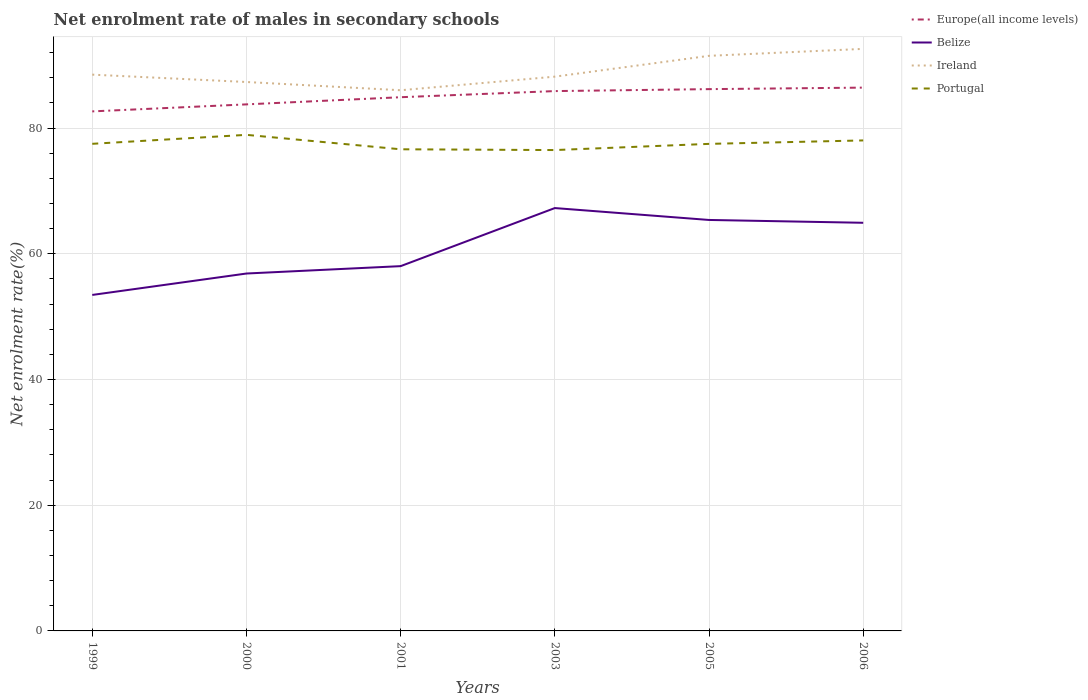How many different coloured lines are there?
Offer a very short reply. 4. Does the line corresponding to Ireland intersect with the line corresponding to Portugal?
Your answer should be very brief. No. Is the number of lines equal to the number of legend labels?
Offer a very short reply. Yes. Across all years, what is the maximum net enrolment rate of males in secondary schools in Belize?
Your answer should be compact. 53.45. In which year was the net enrolment rate of males in secondary schools in Belize maximum?
Provide a short and direct response. 1999. What is the total net enrolment rate of males in secondary schools in Europe(all income levels) in the graph?
Your response must be concise. -2.26. What is the difference between the highest and the second highest net enrolment rate of males in secondary schools in Europe(all income levels)?
Ensure brevity in your answer.  3.78. Is the net enrolment rate of males in secondary schools in Ireland strictly greater than the net enrolment rate of males in secondary schools in Europe(all income levels) over the years?
Make the answer very short. No. How many lines are there?
Ensure brevity in your answer.  4. Where does the legend appear in the graph?
Your response must be concise. Top right. What is the title of the graph?
Give a very brief answer. Net enrolment rate of males in secondary schools. Does "Lower middle income" appear as one of the legend labels in the graph?
Your answer should be very brief. No. What is the label or title of the X-axis?
Offer a terse response. Years. What is the label or title of the Y-axis?
Keep it short and to the point. Net enrolment rate(%). What is the Net enrolment rate(%) of Europe(all income levels) in 1999?
Provide a succinct answer. 82.65. What is the Net enrolment rate(%) in Belize in 1999?
Provide a succinct answer. 53.45. What is the Net enrolment rate(%) in Ireland in 1999?
Make the answer very short. 88.5. What is the Net enrolment rate(%) in Portugal in 1999?
Provide a succinct answer. 77.49. What is the Net enrolment rate(%) of Europe(all income levels) in 2000?
Give a very brief answer. 83.77. What is the Net enrolment rate(%) in Belize in 2000?
Give a very brief answer. 56.86. What is the Net enrolment rate(%) of Ireland in 2000?
Make the answer very short. 87.33. What is the Net enrolment rate(%) in Portugal in 2000?
Provide a succinct answer. 78.92. What is the Net enrolment rate(%) in Europe(all income levels) in 2001?
Your response must be concise. 84.9. What is the Net enrolment rate(%) in Belize in 2001?
Offer a terse response. 58.03. What is the Net enrolment rate(%) in Ireland in 2001?
Your response must be concise. 86.01. What is the Net enrolment rate(%) in Portugal in 2001?
Ensure brevity in your answer.  76.62. What is the Net enrolment rate(%) of Europe(all income levels) in 2003?
Provide a short and direct response. 85.88. What is the Net enrolment rate(%) of Belize in 2003?
Your response must be concise. 67.27. What is the Net enrolment rate(%) of Ireland in 2003?
Offer a terse response. 88.18. What is the Net enrolment rate(%) in Portugal in 2003?
Give a very brief answer. 76.5. What is the Net enrolment rate(%) in Europe(all income levels) in 2005?
Give a very brief answer. 86.19. What is the Net enrolment rate(%) in Belize in 2005?
Ensure brevity in your answer.  65.38. What is the Net enrolment rate(%) in Ireland in 2005?
Ensure brevity in your answer.  91.49. What is the Net enrolment rate(%) in Portugal in 2005?
Your answer should be compact. 77.48. What is the Net enrolment rate(%) in Europe(all income levels) in 2006?
Your answer should be very brief. 86.43. What is the Net enrolment rate(%) of Belize in 2006?
Make the answer very short. 64.93. What is the Net enrolment rate(%) in Ireland in 2006?
Make the answer very short. 92.59. What is the Net enrolment rate(%) in Portugal in 2006?
Your answer should be very brief. 78.03. Across all years, what is the maximum Net enrolment rate(%) in Europe(all income levels)?
Offer a terse response. 86.43. Across all years, what is the maximum Net enrolment rate(%) in Belize?
Offer a very short reply. 67.27. Across all years, what is the maximum Net enrolment rate(%) of Ireland?
Make the answer very short. 92.59. Across all years, what is the maximum Net enrolment rate(%) of Portugal?
Your answer should be compact. 78.92. Across all years, what is the minimum Net enrolment rate(%) of Europe(all income levels)?
Provide a succinct answer. 82.65. Across all years, what is the minimum Net enrolment rate(%) of Belize?
Your answer should be compact. 53.45. Across all years, what is the minimum Net enrolment rate(%) of Ireland?
Offer a very short reply. 86.01. Across all years, what is the minimum Net enrolment rate(%) in Portugal?
Offer a terse response. 76.5. What is the total Net enrolment rate(%) in Europe(all income levels) in the graph?
Your answer should be very brief. 509.82. What is the total Net enrolment rate(%) of Belize in the graph?
Your answer should be very brief. 365.92. What is the total Net enrolment rate(%) in Ireland in the graph?
Make the answer very short. 534.1. What is the total Net enrolment rate(%) of Portugal in the graph?
Your answer should be very brief. 465.05. What is the difference between the Net enrolment rate(%) of Europe(all income levels) in 1999 and that in 2000?
Make the answer very short. -1.12. What is the difference between the Net enrolment rate(%) of Belize in 1999 and that in 2000?
Your answer should be compact. -3.41. What is the difference between the Net enrolment rate(%) of Ireland in 1999 and that in 2000?
Ensure brevity in your answer.  1.17. What is the difference between the Net enrolment rate(%) in Portugal in 1999 and that in 2000?
Offer a very short reply. -1.43. What is the difference between the Net enrolment rate(%) in Europe(all income levels) in 1999 and that in 2001?
Your answer should be compact. -2.26. What is the difference between the Net enrolment rate(%) of Belize in 1999 and that in 2001?
Make the answer very short. -4.58. What is the difference between the Net enrolment rate(%) in Ireland in 1999 and that in 2001?
Provide a succinct answer. 2.48. What is the difference between the Net enrolment rate(%) in Portugal in 1999 and that in 2001?
Your answer should be very brief. 0.87. What is the difference between the Net enrolment rate(%) in Europe(all income levels) in 1999 and that in 2003?
Make the answer very short. -3.23. What is the difference between the Net enrolment rate(%) of Belize in 1999 and that in 2003?
Provide a succinct answer. -13.82. What is the difference between the Net enrolment rate(%) in Ireland in 1999 and that in 2003?
Give a very brief answer. 0.32. What is the difference between the Net enrolment rate(%) in Portugal in 1999 and that in 2003?
Your response must be concise. 0.99. What is the difference between the Net enrolment rate(%) of Europe(all income levels) in 1999 and that in 2005?
Make the answer very short. -3.54. What is the difference between the Net enrolment rate(%) of Belize in 1999 and that in 2005?
Provide a short and direct response. -11.93. What is the difference between the Net enrolment rate(%) in Ireland in 1999 and that in 2005?
Give a very brief answer. -2.99. What is the difference between the Net enrolment rate(%) in Portugal in 1999 and that in 2005?
Provide a short and direct response. 0.01. What is the difference between the Net enrolment rate(%) of Europe(all income levels) in 1999 and that in 2006?
Keep it short and to the point. -3.78. What is the difference between the Net enrolment rate(%) of Belize in 1999 and that in 2006?
Ensure brevity in your answer.  -11.48. What is the difference between the Net enrolment rate(%) of Ireland in 1999 and that in 2006?
Give a very brief answer. -4.1. What is the difference between the Net enrolment rate(%) in Portugal in 1999 and that in 2006?
Keep it short and to the point. -0.54. What is the difference between the Net enrolment rate(%) in Europe(all income levels) in 2000 and that in 2001?
Offer a very short reply. -1.14. What is the difference between the Net enrolment rate(%) of Belize in 2000 and that in 2001?
Provide a short and direct response. -1.17. What is the difference between the Net enrolment rate(%) of Ireland in 2000 and that in 2001?
Make the answer very short. 1.31. What is the difference between the Net enrolment rate(%) in Portugal in 2000 and that in 2001?
Make the answer very short. 2.3. What is the difference between the Net enrolment rate(%) in Europe(all income levels) in 2000 and that in 2003?
Your answer should be compact. -2.11. What is the difference between the Net enrolment rate(%) of Belize in 2000 and that in 2003?
Give a very brief answer. -10.41. What is the difference between the Net enrolment rate(%) of Ireland in 2000 and that in 2003?
Provide a succinct answer. -0.85. What is the difference between the Net enrolment rate(%) of Portugal in 2000 and that in 2003?
Your answer should be very brief. 2.42. What is the difference between the Net enrolment rate(%) in Europe(all income levels) in 2000 and that in 2005?
Keep it short and to the point. -2.42. What is the difference between the Net enrolment rate(%) in Belize in 2000 and that in 2005?
Provide a succinct answer. -8.52. What is the difference between the Net enrolment rate(%) in Ireland in 2000 and that in 2005?
Give a very brief answer. -4.16. What is the difference between the Net enrolment rate(%) in Portugal in 2000 and that in 2005?
Give a very brief answer. 1.44. What is the difference between the Net enrolment rate(%) of Europe(all income levels) in 2000 and that in 2006?
Provide a succinct answer. -2.67. What is the difference between the Net enrolment rate(%) of Belize in 2000 and that in 2006?
Provide a succinct answer. -8.07. What is the difference between the Net enrolment rate(%) of Ireland in 2000 and that in 2006?
Your response must be concise. -5.27. What is the difference between the Net enrolment rate(%) of Portugal in 2000 and that in 2006?
Your answer should be compact. 0.89. What is the difference between the Net enrolment rate(%) of Europe(all income levels) in 2001 and that in 2003?
Ensure brevity in your answer.  -0.97. What is the difference between the Net enrolment rate(%) of Belize in 2001 and that in 2003?
Provide a short and direct response. -9.24. What is the difference between the Net enrolment rate(%) in Ireland in 2001 and that in 2003?
Your answer should be very brief. -2.16. What is the difference between the Net enrolment rate(%) in Portugal in 2001 and that in 2003?
Your answer should be compact. 0.12. What is the difference between the Net enrolment rate(%) of Europe(all income levels) in 2001 and that in 2005?
Offer a terse response. -1.29. What is the difference between the Net enrolment rate(%) in Belize in 2001 and that in 2005?
Provide a short and direct response. -7.35. What is the difference between the Net enrolment rate(%) in Ireland in 2001 and that in 2005?
Your answer should be compact. -5.47. What is the difference between the Net enrolment rate(%) of Portugal in 2001 and that in 2005?
Provide a short and direct response. -0.86. What is the difference between the Net enrolment rate(%) in Europe(all income levels) in 2001 and that in 2006?
Provide a short and direct response. -1.53. What is the difference between the Net enrolment rate(%) of Belize in 2001 and that in 2006?
Keep it short and to the point. -6.9. What is the difference between the Net enrolment rate(%) of Ireland in 2001 and that in 2006?
Offer a terse response. -6.58. What is the difference between the Net enrolment rate(%) of Portugal in 2001 and that in 2006?
Keep it short and to the point. -1.41. What is the difference between the Net enrolment rate(%) of Europe(all income levels) in 2003 and that in 2005?
Your answer should be compact. -0.31. What is the difference between the Net enrolment rate(%) in Belize in 2003 and that in 2005?
Ensure brevity in your answer.  1.89. What is the difference between the Net enrolment rate(%) in Ireland in 2003 and that in 2005?
Provide a short and direct response. -3.31. What is the difference between the Net enrolment rate(%) of Portugal in 2003 and that in 2005?
Give a very brief answer. -0.98. What is the difference between the Net enrolment rate(%) of Europe(all income levels) in 2003 and that in 2006?
Offer a very short reply. -0.55. What is the difference between the Net enrolment rate(%) of Belize in 2003 and that in 2006?
Offer a very short reply. 2.34. What is the difference between the Net enrolment rate(%) in Ireland in 2003 and that in 2006?
Your answer should be compact. -4.42. What is the difference between the Net enrolment rate(%) of Portugal in 2003 and that in 2006?
Keep it short and to the point. -1.53. What is the difference between the Net enrolment rate(%) of Europe(all income levels) in 2005 and that in 2006?
Provide a short and direct response. -0.24. What is the difference between the Net enrolment rate(%) of Belize in 2005 and that in 2006?
Keep it short and to the point. 0.45. What is the difference between the Net enrolment rate(%) of Ireland in 2005 and that in 2006?
Provide a short and direct response. -1.11. What is the difference between the Net enrolment rate(%) in Portugal in 2005 and that in 2006?
Ensure brevity in your answer.  -0.55. What is the difference between the Net enrolment rate(%) of Europe(all income levels) in 1999 and the Net enrolment rate(%) of Belize in 2000?
Your answer should be very brief. 25.79. What is the difference between the Net enrolment rate(%) of Europe(all income levels) in 1999 and the Net enrolment rate(%) of Ireland in 2000?
Ensure brevity in your answer.  -4.68. What is the difference between the Net enrolment rate(%) in Europe(all income levels) in 1999 and the Net enrolment rate(%) in Portugal in 2000?
Keep it short and to the point. 3.73. What is the difference between the Net enrolment rate(%) of Belize in 1999 and the Net enrolment rate(%) of Ireland in 2000?
Ensure brevity in your answer.  -33.88. What is the difference between the Net enrolment rate(%) in Belize in 1999 and the Net enrolment rate(%) in Portugal in 2000?
Your response must be concise. -25.47. What is the difference between the Net enrolment rate(%) of Ireland in 1999 and the Net enrolment rate(%) of Portugal in 2000?
Offer a terse response. 9.58. What is the difference between the Net enrolment rate(%) of Europe(all income levels) in 1999 and the Net enrolment rate(%) of Belize in 2001?
Offer a very short reply. 24.62. What is the difference between the Net enrolment rate(%) in Europe(all income levels) in 1999 and the Net enrolment rate(%) in Ireland in 2001?
Provide a short and direct response. -3.36. What is the difference between the Net enrolment rate(%) of Europe(all income levels) in 1999 and the Net enrolment rate(%) of Portugal in 2001?
Your response must be concise. 6.03. What is the difference between the Net enrolment rate(%) of Belize in 1999 and the Net enrolment rate(%) of Ireland in 2001?
Give a very brief answer. -32.56. What is the difference between the Net enrolment rate(%) of Belize in 1999 and the Net enrolment rate(%) of Portugal in 2001?
Ensure brevity in your answer.  -23.17. What is the difference between the Net enrolment rate(%) in Ireland in 1999 and the Net enrolment rate(%) in Portugal in 2001?
Make the answer very short. 11.87. What is the difference between the Net enrolment rate(%) of Europe(all income levels) in 1999 and the Net enrolment rate(%) of Belize in 2003?
Make the answer very short. 15.38. What is the difference between the Net enrolment rate(%) of Europe(all income levels) in 1999 and the Net enrolment rate(%) of Ireland in 2003?
Offer a terse response. -5.53. What is the difference between the Net enrolment rate(%) of Europe(all income levels) in 1999 and the Net enrolment rate(%) of Portugal in 2003?
Your answer should be compact. 6.15. What is the difference between the Net enrolment rate(%) of Belize in 1999 and the Net enrolment rate(%) of Ireland in 2003?
Your answer should be compact. -34.73. What is the difference between the Net enrolment rate(%) in Belize in 1999 and the Net enrolment rate(%) in Portugal in 2003?
Your answer should be very brief. -23.05. What is the difference between the Net enrolment rate(%) in Ireland in 1999 and the Net enrolment rate(%) in Portugal in 2003?
Your answer should be compact. 12. What is the difference between the Net enrolment rate(%) of Europe(all income levels) in 1999 and the Net enrolment rate(%) of Belize in 2005?
Your response must be concise. 17.27. What is the difference between the Net enrolment rate(%) in Europe(all income levels) in 1999 and the Net enrolment rate(%) in Ireland in 2005?
Your answer should be very brief. -8.84. What is the difference between the Net enrolment rate(%) in Europe(all income levels) in 1999 and the Net enrolment rate(%) in Portugal in 2005?
Make the answer very short. 5.17. What is the difference between the Net enrolment rate(%) in Belize in 1999 and the Net enrolment rate(%) in Ireland in 2005?
Give a very brief answer. -38.04. What is the difference between the Net enrolment rate(%) in Belize in 1999 and the Net enrolment rate(%) in Portugal in 2005?
Offer a very short reply. -24.03. What is the difference between the Net enrolment rate(%) in Ireland in 1999 and the Net enrolment rate(%) in Portugal in 2005?
Ensure brevity in your answer.  11.01. What is the difference between the Net enrolment rate(%) of Europe(all income levels) in 1999 and the Net enrolment rate(%) of Belize in 2006?
Offer a terse response. 17.72. What is the difference between the Net enrolment rate(%) in Europe(all income levels) in 1999 and the Net enrolment rate(%) in Ireland in 2006?
Ensure brevity in your answer.  -9.95. What is the difference between the Net enrolment rate(%) in Europe(all income levels) in 1999 and the Net enrolment rate(%) in Portugal in 2006?
Provide a short and direct response. 4.62. What is the difference between the Net enrolment rate(%) in Belize in 1999 and the Net enrolment rate(%) in Ireland in 2006?
Your answer should be very brief. -39.14. What is the difference between the Net enrolment rate(%) in Belize in 1999 and the Net enrolment rate(%) in Portugal in 2006?
Offer a terse response. -24.58. What is the difference between the Net enrolment rate(%) in Ireland in 1999 and the Net enrolment rate(%) in Portugal in 2006?
Offer a terse response. 10.46. What is the difference between the Net enrolment rate(%) in Europe(all income levels) in 2000 and the Net enrolment rate(%) in Belize in 2001?
Make the answer very short. 25.73. What is the difference between the Net enrolment rate(%) of Europe(all income levels) in 2000 and the Net enrolment rate(%) of Ireland in 2001?
Provide a succinct answer. -2.25. What is the difference between the Net enrolment rate(%) of Europe(all income levels) in 2000 and the Net enrolment rate(%) of Portugal in 2001?
Make the answer very short. 7.14. What is the difference between the Net enrolment rate(%) in Belize in 2000 and the Net enrolment rate(%) in Ireland in 2001?
Ensure brevity in your answer.  -29.16. What is the difference between the Net enrolment rate(%) in Belize in 2000 and the Net enrolment rate(%) in Portugal in 2001?
Ensure brevity in your answer.  -19.77. What is the difference between the Net enrolment rate(%) of Ireland in 2000 and the Net enrolment rate(%) of Portugal in 2001?
Give a very brief answer. 10.7. What is the difference between the Net enrolment rate(%) in Europe(all income levels) in 2000 and the Net enrolment rate(%) in Belize in 2003?
Ensure brevity in your answer.  16.5. What is the difference between the Net enrolment rate(%) in Europe(all income levels) in 2000 and the Net enrolment rate(%) in Ireland in 2003?
Your answer should be very brief. -4.41. What is the difference between the Net enrolment rate(%) in Europe(all income levels) in 2000 and the Net enrolment rate(%) in Portugal in 2003?
Offer a terse response. 7.27. What is the difference between the Net enrolment rate(%) of Belize in 2000 and the Net enrolment rate(%) of Ireland in 2003?
Ensure brevity in your answer.  -31.32. What is the difference between the Net enrolment rate(%) in Belize in 2000 and the Net enrolment rate(%) in Portugal in 2003?
Ensure brevity in your answer.  -19.64. What is the difference between the Net enrolment rate(%) of Ireland in 2000 and the Net enrolment rate(%) of Portugal in 2003?
Your response must be concise. 10.83. What is the difference between the Net enrolment rate(%) of Europe(all income levels) in 2000 and the Net enrolment rate(%) of Belize in 2005?
Provide a succinct answer. 18.39. What is the difference between the Net enrolment rate(%) in Europe(all income levels) in 2000 and the Net enrolment rate(%) in Ireland in 2005?
Your answer should be compact. -7.72. What is the difference between the Net enrolment rate(%) of Europe(all income levels) in 2000 and the Net enrolment rate(%) of Portugal in 2005?
Offer a terse response. 6.28. What is the difference between the Net enrolment rate(%) in Belize in 2000 and the Net enrolment rate(%) in Ireland in 2005?
Keep it short and to the point. -34.63. What is the difference between the Net enrolment rate(%) of Belize in 2000 and the Net enrolment rate(%) of Portugal in 2005?
Your answer should be compact. -20.63. What is the difference between the Net enrolment rate(%) in Ireland in 2000 and the Net enrolment rate(%) in Portugal in 2005?
Your answer should be very brief. 9.84. What is the difference between the Net enrolment rate(%) in Europe(all income levels) in 2000 and the Net enrolment rate(%) in Belize in 2006?
Your answer should be compact. 18.84. What is the difference between the Net enrolment rate(%) of Europe(all income levels) in 2000 and the Net enrolment rate(%) of Ireland in 2006?
Your response must be concise. -8.83. What is the difference between the Net enrolment rate(%) of Europe(all income levels) in 2000 and the Net enrolment rate(%) of Portugal in 2006?
Your response must be concise. 5.73. What is the difference between the Net enrolment rate(%) of Belize in 2000 and the Net enrolment rate(%) of Ireland in 2006?
Your response must be concise. -35.74. What is the difference between the Net enrolment rate(%) in Belize in 2000 and the Net enrolment rate(%) in Portugal in 2006?
Your response must be concise. -21.17. What is the difference between the Net enrolment rate(%) in Ireland in 2000 and the Net enrolment rate(%) in Portugal in 2006?
Ensure brevity in your answer.  9.29. What is the difference between the Net enrolment rate(%) of Europe(all income levels) in 2001 and the Net enrolment rate(%) of Belize in 2003?
Give a very brief answer. 17.63. What is the difference between the Net enrolment rate(%) in Europe(all income levels) in 2001 and the Net enrolment rate(%) in Ireland in 2003?
Make the answer very short. -3.27. What is the difference between the Net enrolment rate(%) in Europe(all income levels) in 2001 and the Net enrolment rate(%) in Portugal in 2003?
Offer a terse response. 8.41. What is the difference between the Net enrolment rate(%) of Belize in 2001 and the Net enrolment rate(%) of Ireland in 2003?
Your answer should be compact. -30.15. What is the difference between the Net enrolment rate(%) of Belize in 2001 and the Net enrolment rate(%) of Portugal in 2003?
Provide a succinct answer. -18.47. What is the difference between the Net enrolment rate(%) of Ireland in 2001 and the Net enrolment rate(%) of Portugal in 2003?
Your response must be concise. 9.52. What is the difference between the Net enrolment rate(%) in Europe(all income levels) in 2001 and the Net enrolment rate(%) in Belize in 2005?
Provide a short and direct response. 19.53. What is the difference between the Net enrolment rate(%) in Europe(all income levels) in 2001 and the Net enrolment rate(%) in Ireland in 2005?
Offer a terse response. -6.58. What is the difference between the Net enrolment rate(%) in Europe(all income levels) in 2001 and the Net enrolment rate(%) in Portugal in 2005?
Ensure brevity in your answer.  7.42. What is the difference between the Net enrolment rate(%) in Belize in 2001 and the Net enrolment rate(%) in Ireland in 2005?
Your answer should be compact. -33.46. What is the difference between the Net enrolment rate(%) of Belize in 2001 and the Net enrolment rate(%) of Portugal in 2005?
Keep it short and to the point. -19.45. What is the difference between the Net enrolment rate(%) of Ireland in 2001 and the Net enrolment rate(%) of Portugal in 2005?
Your answer should be very brief. 8.53. What is the difference between the Net enrolment rate(%) of Europe(all income levels) in 2001 and the Net enrolment rate(%) of Belize in 2006?
Make the answer very short. 19.98. What is the difference between the Net enrolment rate(%) of Europe(all income levels) in 2001 and the Net enrolment rate(%) of Ireland in 2006?
Keep it short and to the point. -7.69. What is the difference between the Net enrolment rate(%) of Europe(all income levels) in 2001 and the Net enrolment rate(%) of Portugal in 2006?
Offer a terse response. 6.87. What is the difference between the Net enrolment rate(%) of Belize in 2001 and the Net enrolment rate(%) of Ireland in 2006?
Make the answer very short. -34.56. What is the difference between the Net enrolment rate(%) of Belize in 2001 and the Net enrolment rate(%) of Portugal in 2006?
Offer a very short reply. -20. What is the difference between the Net enrolment rate(%) of Ireland in 2001 and the Net enrolment rate(%) of Portugal in 2006?
Your answer should be compact. 7.98. What is the difference between the Net enrolment rate(%) in Europe(all income levels) in 2003 and the Net enrolment rate(%) in Belize in 2005?
Your answer should be compact. 20.5. What is the difference between the Net enrolment rate(%) in Europe(all income levels) in 2003 and the Net enrolment rate(%) in Ireland in 2005?
Provide a succinct answer. -5.61. What is the difference between the Net enrolment rate(%) in Europe(all income levels) in 2003 and the Net enrolment rate(%) in Portugal in 2005?
Provide a succinct answer. 8.4. What is the difference between the Net enrolment rate(%) of Belize in 2003 and the Net enrolment rate(%) of Ireland in 2005?
Provide a succinct answer. -24.22. What is the difference between the Net enrolment rate(%) of Belize in 2003 and the Net enrolment rate(%) of Portugal in 2005?
Offer a terse response. -10.21. What is the difference between the Net enrolment rate(%) of Ireland in 2003 and the Net enrolment rate(%) of Portugal in 2005?
Make the answer very short. 10.69. What is the difference between the Net enrolment rate(%) in Europe(all income levels) in 2003 and the Net enrolment rate(%) in Belize in 2006?
Ensure brevity in your answer.  20.95. What is the difference between the Net enrolment rate(%) of Europe(all income levels) in 2003 and the Net enrolment rate(%) of Ireland in 2006?
Offer a very short reply. -6.72. What is the difference between the Net enrolment rate(%) in Europe(all income levels) in 2003 and the Net enrolment rate(%) in Portugal in 2006?
Give a very brief answer. 7.85. What is the difference between the Net enrolment rate(%) of Belize in 2003 and the Net enrolment rate(%) of Ireland in 2006?
Keep it short and to the point. -25.32. What is the difference between the Net enrolment rate(%) of Belize in 2003 and the Net enrolment rate(%) of Portugal in 2006?
Your response must be concise. -10.76. What is the difference between the Net enrolment rate(%) of Ireland in 2003 and the Net enrolment rate(%) of Portugal in 2006?
Offer a very short reply. 10.15. What is the difference between the Net enrolment rate(%) in Europe(all income levels) in 2005 and the Net enrolment rate(%) in Belize in 2006?
Your response must be concise. 21.26. What is the difference between the Net enrolment rate(%) in Europe(all income levels) in 2005 and the Net enrolment rate(%) in Ireland in 2006?
Offer a terse response. -6.4. What is the difference between the Net enrolment rate(%) in Europe(all income levels) in 2005 and the Net enrolment rate(%) in Portugal in 2006?
Provide a succinct answer. 8.16. What is the difference between the Net enrolment rate(%) of Belize in 2005 and the Net enrolment rate(%) of Ireland in 2006?
Make the answer very short. -27.22. What is the difference between the Net enrolment rate(%) of Belize in 2005 and the Net enrolment rate(%) of Portugal in 2006?
Offer a very short reply. -12.65. What is the difference between the Net enrolment rate(%) in Ireland in 2005 and the Net enrolment rate(%) in Portugal in 2006?
Make the answer very short. 13.46. What is the average Net enrolment rate(%) of Europe(all income levels) per year?
Offer a terse response. 84.97. What is the average Net enrolment rate(%) of Belize per year?
Make the answer very short. 60.99. What is the average Net enrolment rate(%) of Ireland per year?
Your answer should be very brief. 89.02. What is the average Net enrolment rate(%) in Portugal per year?
Your answer should be very brief. 77.51. In the year 1999, what is the difference between the Net enrolment rate(%) in Europe(all income levels) and Net enrolment rate(%) in Belize?
Your response must be concise. 29.2. In the year 1999, what is the difference between the Net enrolment rate(%) of Europe(all income levels) and Net enrolment rate(%) of Ireland?
Offer a very short reply. -5.85. In the year 1999, what is the difference between the Net enrolment rate(%) of Europe(all income levels) and Net enrolment rate(%) of Portugal?
Provide a short and direct response. 5.16. In the year 1999, what is the difference between the Net enrolment rate(%) in Belize and Net enrolment rate(%) in Ireland?
Your answer should be very brief. -35.05. In the year 1999, what is the difference between the Net enrolment rate(%) of Belize and Net enrolment rate(%) of Portugal?
Your answer should be compact. -24.04. In the year 1999, what is the difference between the Net enrolment rate(%) of Ireland and Net enrolment rate(%) of Portugal?
Keep it short and to the point. 11. In the year 2000, what is the difference between the Net enrolment rate(%) of Europe(all income levels) and Net enrolment rate(%) of Belize?
Offer a very short reply. 26.91. In the year 2000, what is the difference between the Net enrolment rate(%) in Europe(all income levels) and Net enrolment rate(%) in Ireland?
Your answer should be compact. -3.56. In the year 2000, what is the difference between the Net enrolment rate(%) of Europe(all income levels) and Net enrolment rate(%) of Portugal?
Keep it short and to the point. 4.85. In the year 2000, what is the difference between the Net enrolment rate(%) of Belize and Net enrolment rate(%) of Ireland?
Your response must be concise. -30.47. In the year 2000, what is the difference between the Net enrolment rate(%) in Belize and Net enrolment rate(%) in Portugal?
Ensure brevity in your answer.  -22.06. In the year 2000, what is the difference between the Net enrolment rate(%) in Ireland and Net enrolment rate(%) in Portugal?
Give a very brief answer. 8.41. In the year 2001, what is the difference between the Net enrolment rate(%) in Europe(all income levels) and Net enrolment rate(%) in Belize?
Provide a succinct answer. 26.87. In the year 2001, what is the difference between the Net enrolment rate(%) in Europe(all income levels) and Net enrolment rate(%) in Ireland?
Make the answer very short. -1.11. In the year 2001, what is the difference between the Net enrolment rate(%) of Europe(all income levels) and Net enrolment rate(%) of Portugal?
Keep it short and to the point. 8.28. In the year 2001, what is the difference between the Net enrolment rate(%) of Belize and Net enrolment rate(%) of Ireland?
Offer a terse response. -27.98. In the year 2001, what is the difference between the Net enrolment rate(%) of Belize and Net enrolment rate(%) of Portugal?
Offer a very short reply. -18.59. In the year 2001, what is the difference between the Net enrolment rate(%) of Ireland and Net enrolment rate(%) of Portugal?
Keep it short and to the point. 9.39. In the year 2003, what is the difference between the Net enrolment rate(%) of Europe(all income levels) and Net enrolment rate(%) of Belize?
Offer a very short reply. 18.61. In the year 2003, what is the difference between the Net enrolment rate(%) in Europe(all income levels) and Net enrolment rate(%) in Ireland?
Keep it short and to the point. -2.3. In the year 2003, what is the difference between the Net enrolment rate(%) of Europe(all income levels) and Net enrolment rate(%) of Portugal?
Keep it short and to the point. 9.38. In the year 2003, what is the difference between the Net enrolment rate(%) in Belize and Net enrolment rate(%) in Ireland?
Offer a terse response. -20.91. In the year 2003, what is the difference between the Net enrolment rate(%) in Belize and Net enrolment rate(%) in Portugal?
Make the answer very short. -9.23. In the year 2003, what is the difference between the Net enrolment rate(%) in Ireland and Net enrolment rate(%) in Portugal?
Make the answer very short. 11.68. In the year 2005, what is the difference between the Net enrolment rate(%) of Europe(all income levels) and Net enrolment rate(%) of Belize?
Offer a very short reply. 20.81. In the year 2005, what is the difference between the Net enrolment rate(%) of Europe(all income levels) and Net enrolment rate(%) of Ireland?
Give a very brief answer. -5.3. In the year 2005, what is the difference between the Net enrolment rate(%) in Europe(all income levels) and Net enrolment rate(%) in Portugal?
Give a very brief answer. 8.71. In the year 2005, what is the difference between the Net enrolment rate(%) of Belize and Net enrolment rate(%) of Ireland?
Provide a short and direct response. -26.11. In the year 2005, what is the difference between the Net enrolment rate(%) of Belize and Net enrolment rate(%) of Portugal?
Provide a short and direct response. -12.1. In the year 2005, what is the difference between the Net enrolment rate(%) in Ireland and Net enrolment rate(%) in Portugal?
Provide a succinct answer. 14.01. In the year 2006, what is the difference between the Net enrolment rate(%) of Europe(all income levels) and Net enrolment rate(%) of Belize?
Your answer should be compact. 21.5. In the year 2006, what is the difference between the Net enrolment rate(%) of Europe(all income levels) and Net enrolment rate(%) of Ireland?
Give a very brief answer. -6.16. In the year 2006, what is the difference between the Net enrolment rate(%) in Europe(all income levels) and Net enrolment rate(%) in Portugal?
Offer a very short reply. 8.4. In the year 2006, what is the difference between the Net enrolment rate(%) of Belize and Net enrolment rate(%) of Ireland?
Make the answer very short. -27.67. In the year 2006, what is the difference between the Net enrolment rate(%) of Belize and Net enrolment rate(%) of Portugal?
Offer a very short reply. -13.1. In the year 2006, what is the difference between the Net enrolment rate(%) of Ireland and Net enrolment rate(%) of Portugal?
Offer a terse response. 14.56. What is the ratio of the Net enrolment rate(%) in Europe(all income levels) in 1999 to that in 2000?
Provide a short and direct response. 0.99. What is the ratio of the Net enrolment rate(%) in Belize in 1999 to that in 2000?
Ensure brevity in your answer.  0.94. What is the ratio of the Net enrolment rate(%) in Ireland in 1999 to that in 2000?
Ensure brevity in your answer.  1.01. What is the ratio of the Net enrolment rate(%) in Portugal in 1999 to that in 2000?
Offer a terse response. 0.98. What is the ratio of the Net enrolment rate(%) of Europe(all income levels) in 1999 to that in 2001?
Offer a terse response. 0.97. What is the ratio of the Net enrolment rate(%) in Belize in 1999 to that in 2001?
Offer a terse response. 0.92. What is the ratio of the Net enrolment rate(%) in Ireland in 1999 to that in 2001?
Ensure brevity in your answer.  1.03. What is the ratio of the Net enrolment rate(%) of Portugal in 1999 to that in 2001?
Offer a very short reply. 1.01. What is the ratio of the Net enrolment rate(%) in Europe(all income levels) in 1999 to that in 2003?
Offer a terse response. 0.96. What is the ratio of the Net enrolment rate(%) in Belize in 1999 to that in 2003?
Offer a terse response. 0.79. What is the ratio of the Net enrolment rate(%) of Europe(all income levels) in 1999 to that in 2005?
Your answer should be compact. 0.96. What is the ratio of the Net enrolment rate(%) in Belize in 1999 to that in 2005?
Your answer should be very brief. 0.82. What is the ratio of the Net enrolment rate(%) of Ireland in 1999 to that in 2005?
Give a very brief answer. 0.97. What is the ratio of the Net enrolment rate(%) in Portugal in 1999 to that in 2005?
Your answer should be compact. 1. What is the ratio of the Net enrolment rate(%) in Europe(all income levels) in 1999 to that in 2006?
Your answer should be compact. 0.96. What is the ratio of the Net enrolment rate(%) in Belize in 1999 to that in 2006?
Your answer should be very brief. 0.82. What is the ratio of the Net enrolment rate(%) in Ireland in 1999 to that in 2006?
Provide a succinct answer. 0.96. What is the ratio of the Net enrolment rate(%) of Europe(all income levels) in 2000 to that in 2001?
Offer a terse response. 0.99. What is the ratio of the Net enrolment rate(%) of Belize in 2000 to that in 2001?
Offer a very short reply. 0.98. What is the ratio of the Net enrolment rate(%) of Ireland in 2000 to that in 2001?
Your answer should be compact. 1.02. What is the ratio of the Net enrolment rate(%) in Europe(all income levels) in 2000 to that in 2003?
Give a very brief answer. 0.98. What is the ratio of the Net enrolment rate(%) of Belize in 2000 to that in 2003?
Offer a very short reply. 0.85. What is the ratio of the Net enrolment rate(%) of Portugal in 2000 to that in 2003?
Provide a short and direct response. 1.03. What is the ratio of the Net enrolment rate(%) in Europe(all income levels) in 2000 to that in 2005?
Provide a succinct answer. 0.97. What is the ratio of the Net enrolment rate(%) in Belize in 2000 to that in 2005?
Provide a succinct answer. 0.87. What is the ratio of the Net enrolment rate(%) in Ireland in 2000 to that in 2005?
Your response must be concise. 0.95. What is the ratio of the Net enrolment rate(%) in Portugal in 2000 to that in 2005?
Provide a succinct answer. 1.02. What is the ratio of the Net enrolment rate(%) of Europe(all income levels) in 2000 to that in 2006?
Offer a very short reply. 0.97. What is the ratio of the Net enrolment rate(%) in Belize in 2000 to that in 2006?
Provide a succinct answer. 0.88. What is the ratio of the Net enrolment rate(%) of Ireland in 2000 to that in 2006?
Your response must be concise. 0.94. What is the ratio of the Net enrolment rate(%) of Portugal in 2000 to that in 2006?
Offer a very short reply. 1.01. What is the ratio of the Net enrolment rate(%) in Europe(all income levels) in 2001 to that in 2003?
Offer a terse response. 0.99. What is the ratio of the Net enrolment rate(%) of Belize in 2001 to that in 2003?
Provide a short and direct response. 0.86. What is the ratio of the Net enrolment rate(%) of Ireland in 2001 to that in 2003?
Keep it short and to the point. 0.98. What is the ratio of the Net enrolment rate(%) of Europe(all income levels) in 2001 to that in 2005?
Provide a succinct answer. 0.99. What is the ratio of the Net enrolment rate(%) of Belize in 2001 to that in 2005?
Ensure brevity in your answer.  0.89. What is the ratio of the Net enrolment rate(%) of Ireland in 2001 to that in 2005?
Provide a succinct answer. 0.94. What is the ratio of the Net enrolment rate(%) of Portugal in 2001 to that in 2005?
Keep it short and to the point. 0.99. What is the ratio of the Net enrolment rate(%) in Europe(all income levels) in 2001 to that in 2006?
Give a very brief answer. 0.98. What is the ratio of the Net enrolment rate(%) of Belize in 2001 to that in 2006?
Keep it short and to the point. 0.89. What is the ratio of the Net enrolment rate(%) of Ireland in 2001 to that in 2006?
Provide a short and direct response. 0.93. What is the ratio of the Net enrolment rate(%) in Portugal in 2001 to that in 2006?
Your answer should be very brief. 0.98. What is the ratio of the Net enrolment rate(%) in Europe(all income levels) in 2003 to that in 2005?
Give a very brief answer. 1. What is the ratio of the Net enrolment rate(%) in Belize in 2003 to that in 2005?
Ensure brevity in your answer.  1.03. What is the ratio of the Net enrolment rate(%) in Ireland in 2003 to that in 2005?
Your response must be concise. 0.96. What is the ratio of the Net enrolment rate(%) of Portugal in 2003 to that in 2005?
Give a very brief answer. 0.99. What is the ratio of the Net enrolment rate(%) of Belize in 2003 to that in 2006?
Your response must be concise. 1.04. What is the ratio of the Net enrolment rate(%) in Ireland in 2003 to that in 2006?
Your answer should be compact. 0.95. What is the ratio of the Net enrolment rate(%) of Portugal in 2003 to that in 2006?
Offer a terse response. 0.98. What is the ratio of the Net enrolment rate(%) of Europe(all income levels) in 2005 to that in 2006?
Provide a succinct answer. 1. What is the ratio of the Net enrolment rate(%) in Portugal in 2005 to that in 2006?
Your answer should be very brief. 0.99. What is the difference between the highest and the second highest Net enrolment rate(%) in Europe(all income levels)?
Give a very brief answer. 0.24. What is the difference between the highest and the second highest Net enrolment rate(%) of Belize?
Give a very brief answer. 1.89. What is the difference between the highest and the second highest Net enrolment rate(%) in Ireland?
Ensure brevity in your answer.  1.11. What is the difference between the highest and the second highest Net enrolment rate(%) of Portugal?
Make the answer very short. 0.89. What is the difference between the highest and the lowest Net enrolment rate(%) in Europe(all income levels)?
Your response must be concise. 3.78. What is the difference between the highest and the lowest Net enrolment rate(%) of Belize?
Offer a terse response. 13.82. What is the difference between the highest and the lowest Net enrolment rate(%) of Ireland?
Offer a terse response. 6.58. What is the difference between the highest and the lowest Net enrolment rate(%) in Portugal?
Keep it short and to the point. 2.42. 